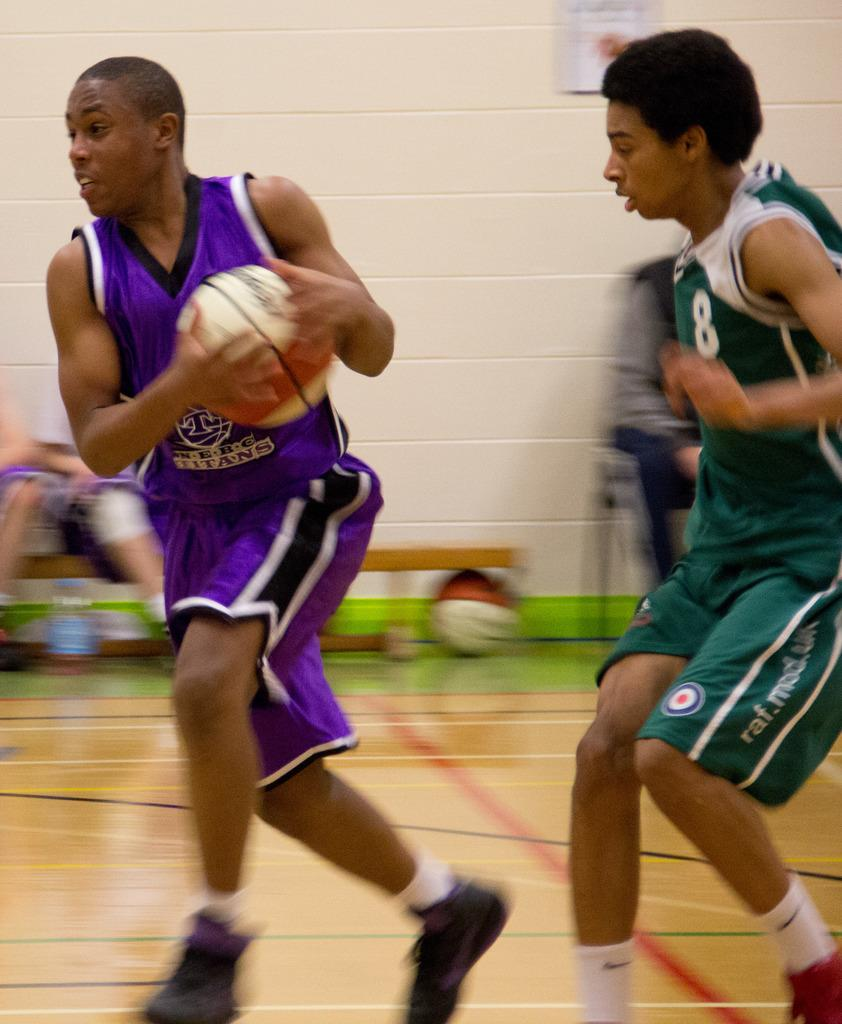<image>
Describe the image concisely. Player number 8 runs after another player holding the ball. 